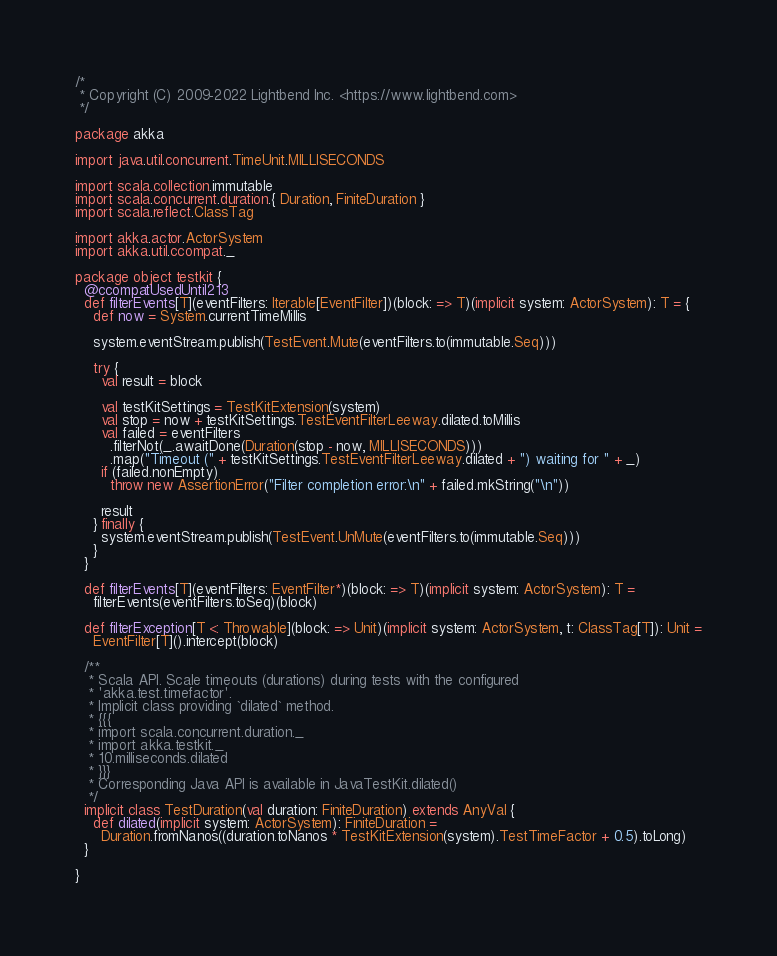Convert code to text. <code><loc_0><loc_0><loc_500><loc_500><_Scala_>/*
 * Copyright (C) 2009-2022 Lightbend Inc. <https://www.lightbend.com>
 */

package akka

import java.util.concurrent.TimeUnit.MILLISECONDS

import scala.collection.immutable
import scala.concurrent.duration.{ Duration, FiniteDuration }
import scala.reflect.ClassTag

import akka.actor.ActorSystem
import akka.util.ccompat._

package object testkit {
  @ccompatUsedUntil213
  def filterEvents[T](eventFilters: Iterable[EventFilter])(block: => T)(implicit system: ActorSystem): T = {
    def now = System.currentTimeMillis

    system.eventStream.publish(TestEvent.Mute(eventFilters.to(immutable.Seq)))

    try {
      val result = block

      val testKitSettings = TestKitExtension(system)
      val stop = now + testKitSettings.TestEventFilterLeeway.dilated.toMillis
      val failed = eventFilters
        .filterNot(_.awaitDone(Duration(stop - now, MILLISECONDS)))
        .map("Timeout (" + testKitSettings.TestEventFilterLeeway.dilated + ") waiting for " + _)
      if (failed.nonEmpty)
        throw new AssertionError("Filter completion error:\n" + failed.mkString("\n"))

      result
    } finally {
      system.eventStream.publish(TestEvent.UnMute(eventFilters.to(immutable.Seq)))
    }
  }

  def filterEvents[T](eventFilters: EventFilter*)(block: => T)(implicit system: ActorSystem): T =
    filterEvents(eventFilters.toSeq)(block)

  def filterException[T <: Throwable](block: => Unit)(implicit system: ActorSystem, t: ClassTag[T]): Unit =
    EventFilter[T]().intercept(block)

  /**
   * Scala API. Scale timeouts (durations) during tests with the configured
   * 'akka.test.timefactor'.
   * Implicit class providing `dilated` method.
   * {{{
   * import scala.concurrent.duration._
   * import akka.testkit._
   * 10.milliseconds.dilated
   * }}}
   * Corresponding Java API is available in JavaTestKit.dilated()
   */
  implicit class TestDuration(val duration: FiniteDuration) extends AnyVal {
    def dilated(implicit system: ActorSystem): FiniteDuration =
      Duration.fromNanos((duration.toNanos * TestKitExtension(system).TestTimeFactor + 0.5).toLong)
  }

}
</code> 